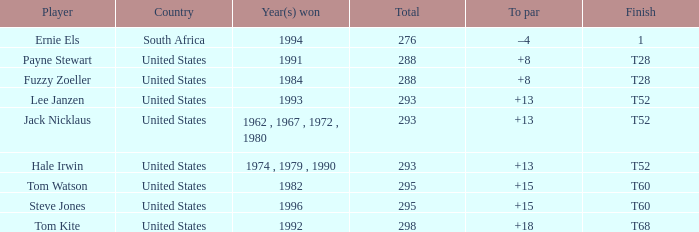Who is the player who won in 1994? Ernie Els. 